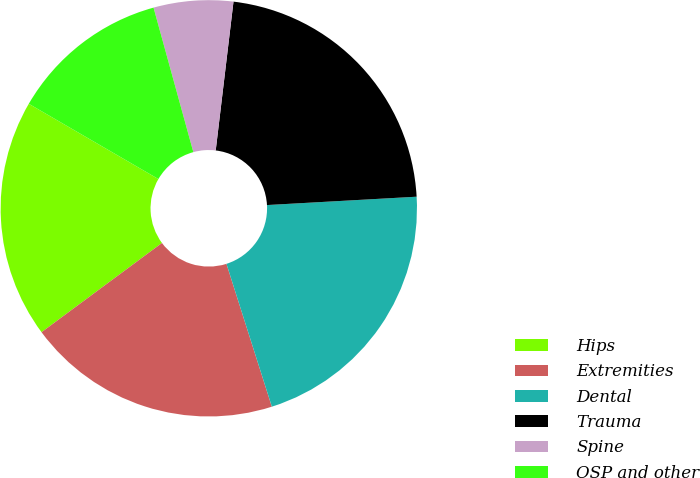<chart> <loc_0><loc_0><loc_500><loc_500><pie_chart><fcel>Hips<fcel>Extremities<fcel>Dental<fcel>Trauma<fcel>Spine<fcel>OSP and other<nl><fcel>18.52%<fcel>19.75%<fcel>20.99%<fcel>22.22%<fcel>6.17%<fcel>12.35%<nl></chart> 